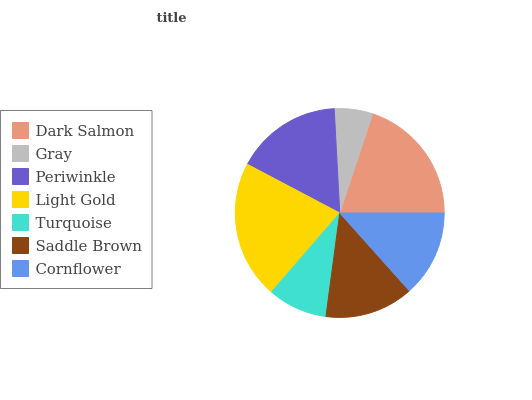Is Gray the minimum?
Answer yes or no. Yes. Is Light Gold the maximum?
Answer yes or no. Yes. Is Periwinkle the minimum?
Answer yes or no. No. Is Periwinkle the maximum?
Answer yes or no. No. Is Periwinkle greater than Gray?
Answer yes or no. Yes. Is Gray less than Periwinkle?
Answer yes or no. Yes. Is Gray greater than Periwinkle?
Answer yes or no. No. Is Periwinkle less than Gray?
Answer yes or no. No. Is Saddle Brown the high median?
Answer yes or no. Yes. Is Saddle Brown the low median?
Answer yes or no. Yes. Is Gray the high median?
Answer yes or no. No. Is Gray the low median?
Answer yes or no. No. 